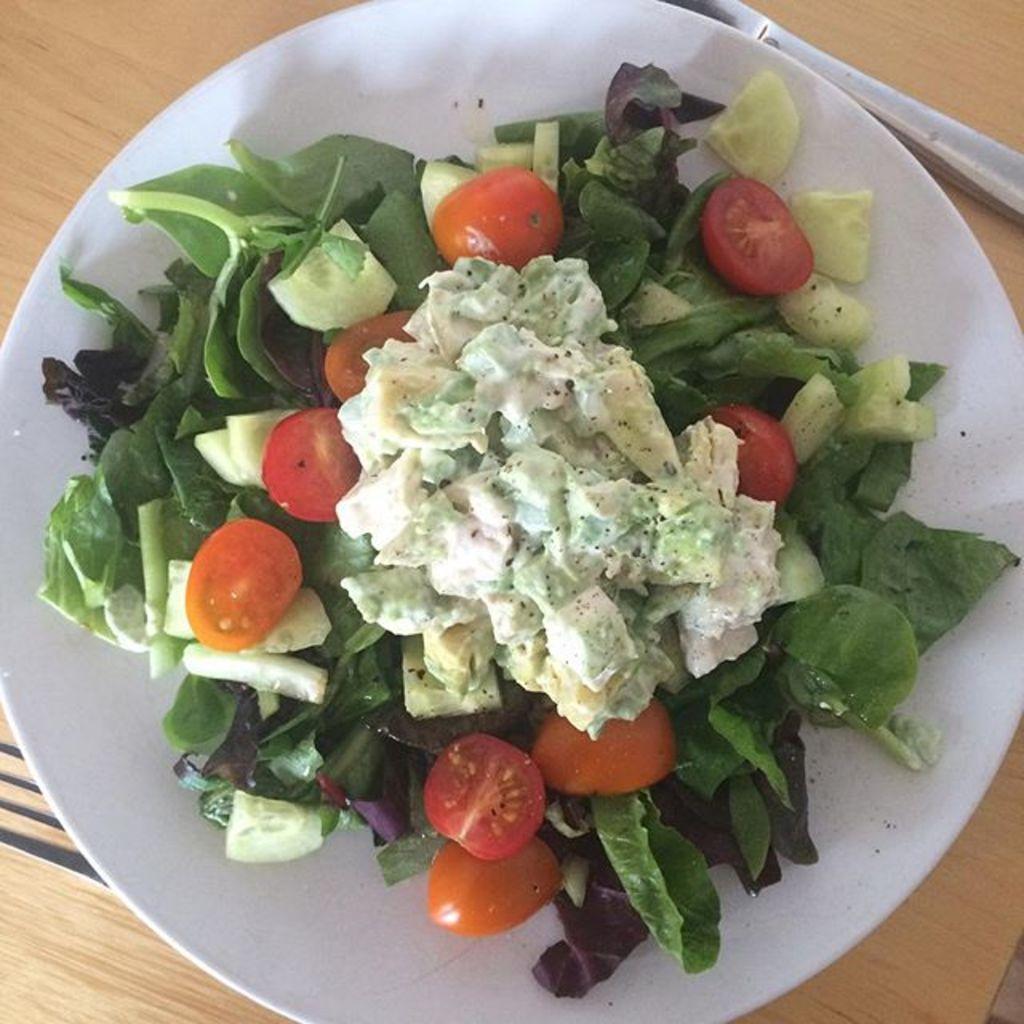Could you give a brief overview of what you see in this image? In this image I can see white colour plate and in it I can see different types of vegetable. I can also see green color leaves and here I can see a fork. 